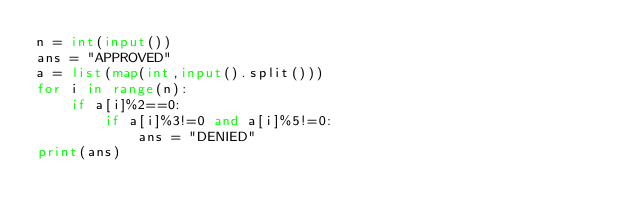Convert code to text. <code><loc_0><loc_0><loc_500><loc_500><_Python_>n = int(input())
ans = "APPROVED"
a = list(map(int,input().split()))
for i in range(n):
    if a[i]%2==0:
        if a[i]%3!=0 and a[i]%5!=0:
            ans = "DENIED"
print(ans)      </code> 